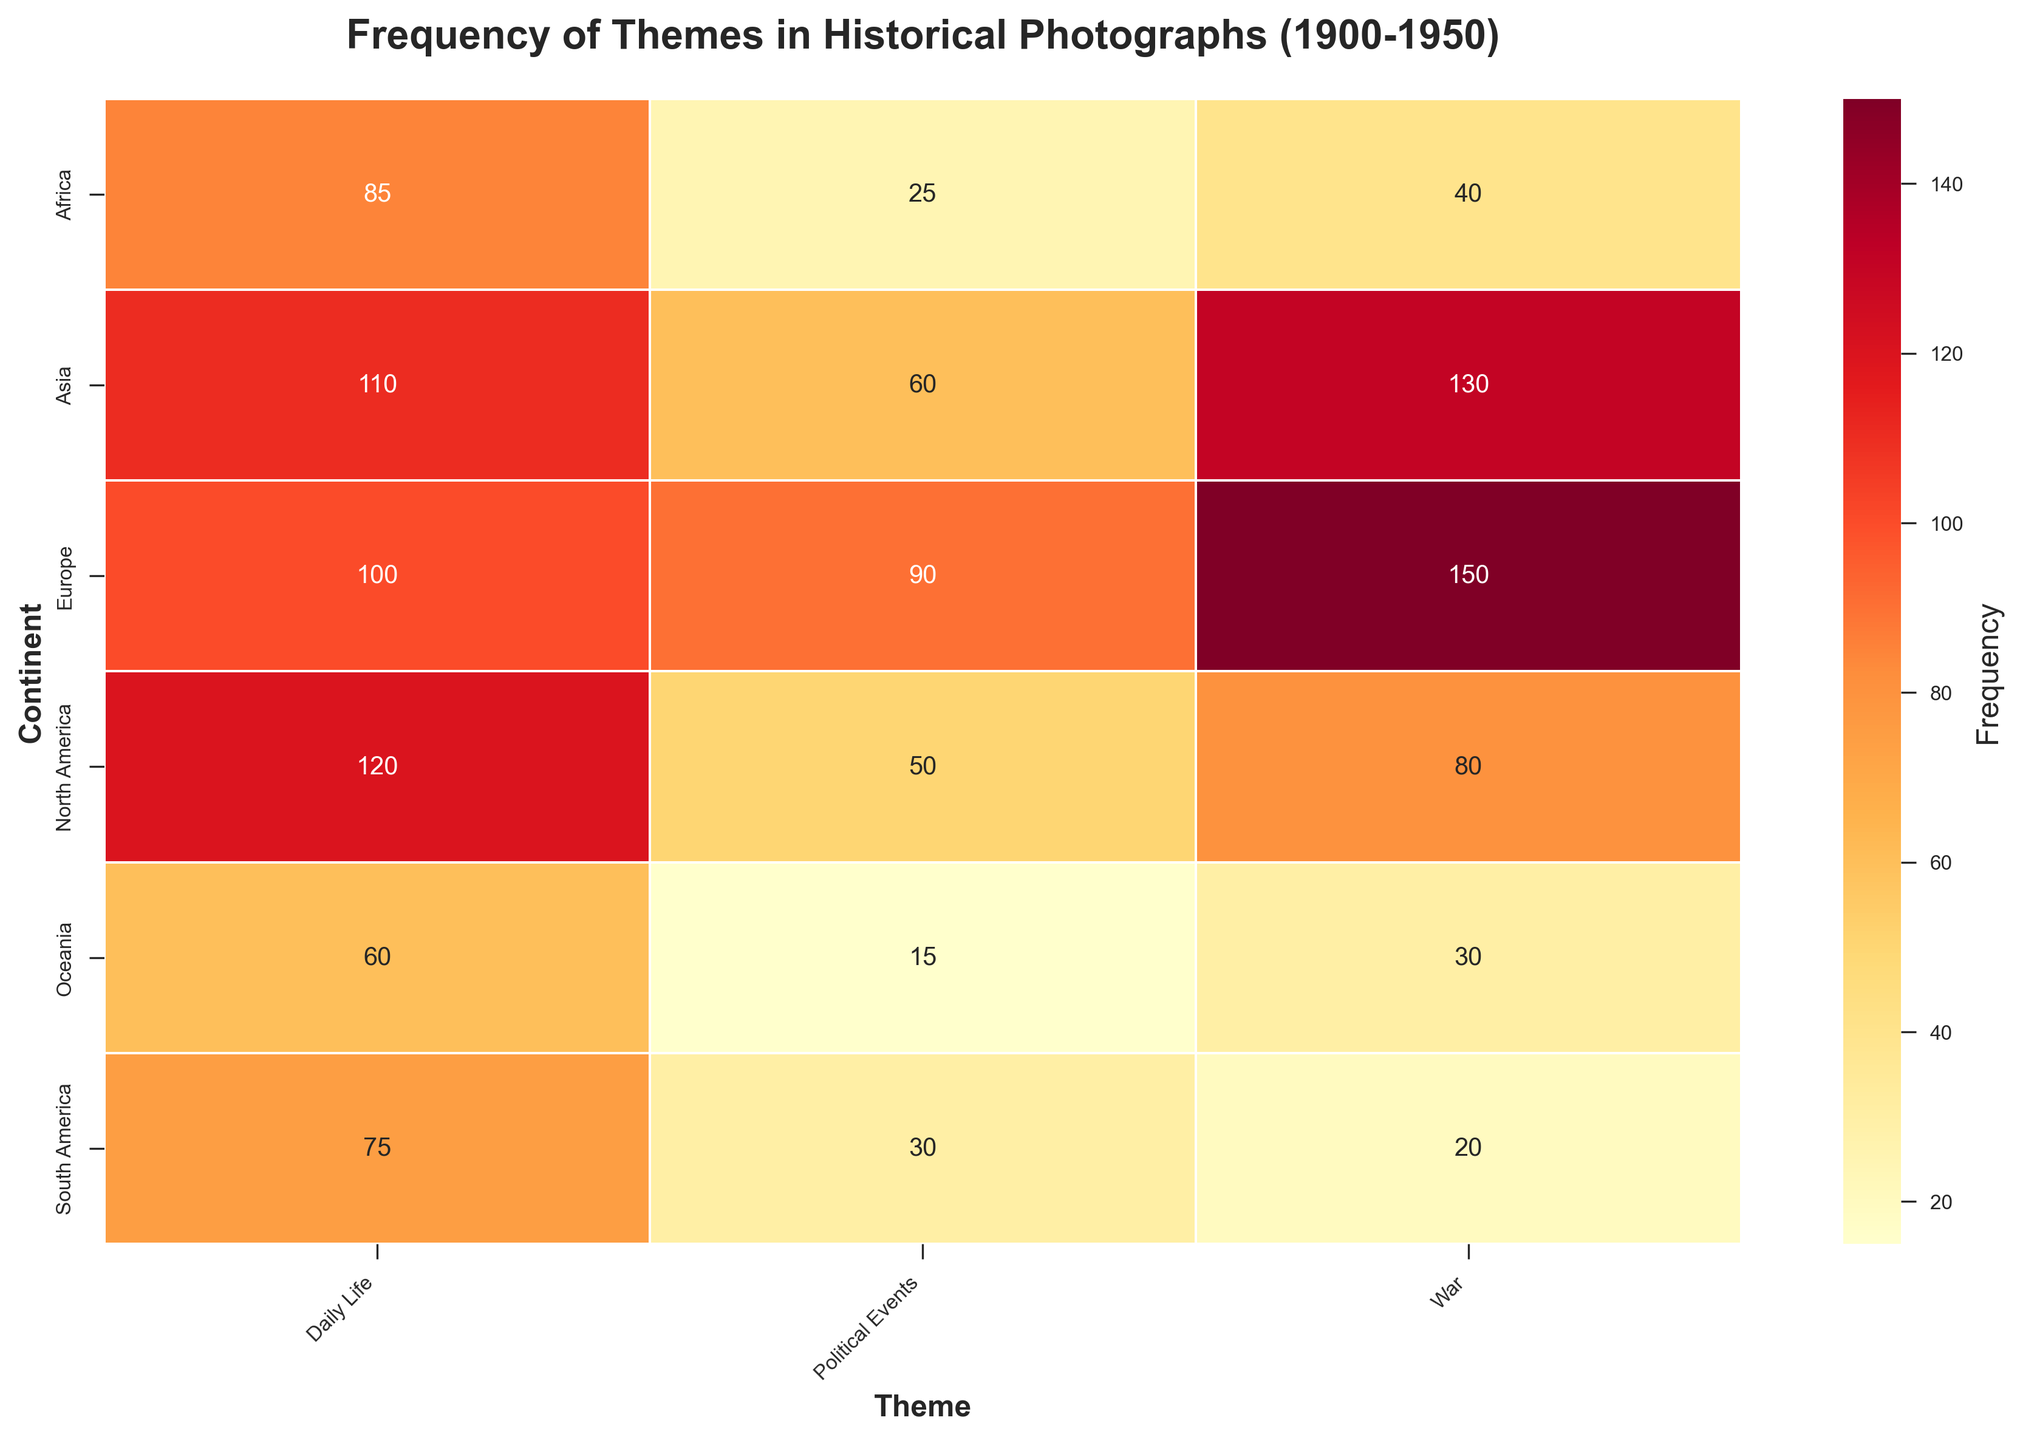What is the theme with the highest frequency in North America? Refer to the North America row in the heatmap and identify the theme with the highest annotated frequency. The highest frequency in the North America row is "Daily Life" with a frequency of 120.
Answer: Daily Life Which continent has the highest frequency for the War theme? Look at the column for the War theme and identify the continent with the highest frequency. The highest number in the War column is 150, which corresponds to Europe.
Answer: Europe What is the combined frequency of Political Events across all continents? Sum the frequencies for the Political Events theme from all continents. The frequencies are 50 (North America) + 30 (South America) + 90 (Europe) + 60 (Asia) + 25 (Africa) + 15 (Oceania).
Answer: 270 Which continent has the lowest overall frequency of photographs considering all themes combined? Sum the frequencies of all themes for each continent and identify the smallest sum. Summing for each continent: North America (250), South America (125), Europe (340), Asia (300), Africa (150), Oceania (105). The lowest is Oceania with 105.
Answer: Oceania What is the ratio of the frequency of War-themed photographs in Europe to those in South America? Divide the frequency of War-themed photographs in Europe by that in South America. The frequencies are 150 (Europe) and 20 (South America), so the ratio is 150/20.
Answer: 7.5 Which theme has the lowest frequency in Asia? Refer to the Asia row and identify the theme with the lowest annotated frequency. In the Asia row, the lowest frequency is for Political Events with 60.
Answer: Political Events What is the difference in frequency of War-themed photographs between Africa and North America? Subtract the frequency of War in Africa from that in North America. The frequencies are 80 (North America) and 40 (Africa), so the difference is 80 - 40.
Answer: 40 In which continent is the frequency of Daily Life photographs nearly the same as that of War photographs? Compare the frequencies of Daily Life and War for each continent and find the one with the closest values. The closest values are in Asia, with Daily Life at 110 and War at 130.
Answer: Asia What percentage of the total photographs do Political Events in Europe represent? Calculate the total number of photographs and then the percentage represented by Political Events in Europe. Total photographs = 250 (North America) + 125 (South America) + 340 (Europe) + 300 (Asia) + 150 (Africa) + 105 (Oceania) = 1270. Percentage for Europe Political Events = (90 / 1270) * 100.
Answer: ≈ 7.09% Which continent has the highest variety in frequency across different themes, based on the maximum and minimum frequencies? Identify the continent with the largest absolute difference between its highest and lowest frequency values for different themes. Calculate for each continent: North America (120 - 50 = 70), South America (75 - 20 = 55), Europe (150 - 90 = 60), Asia (130 - 60 = 70), Africa (85 - 25 = 60), Oceania (60 - 15 = 45). North America and Asia both have a difference of 70, the highest.
Answer: North America, Asia 